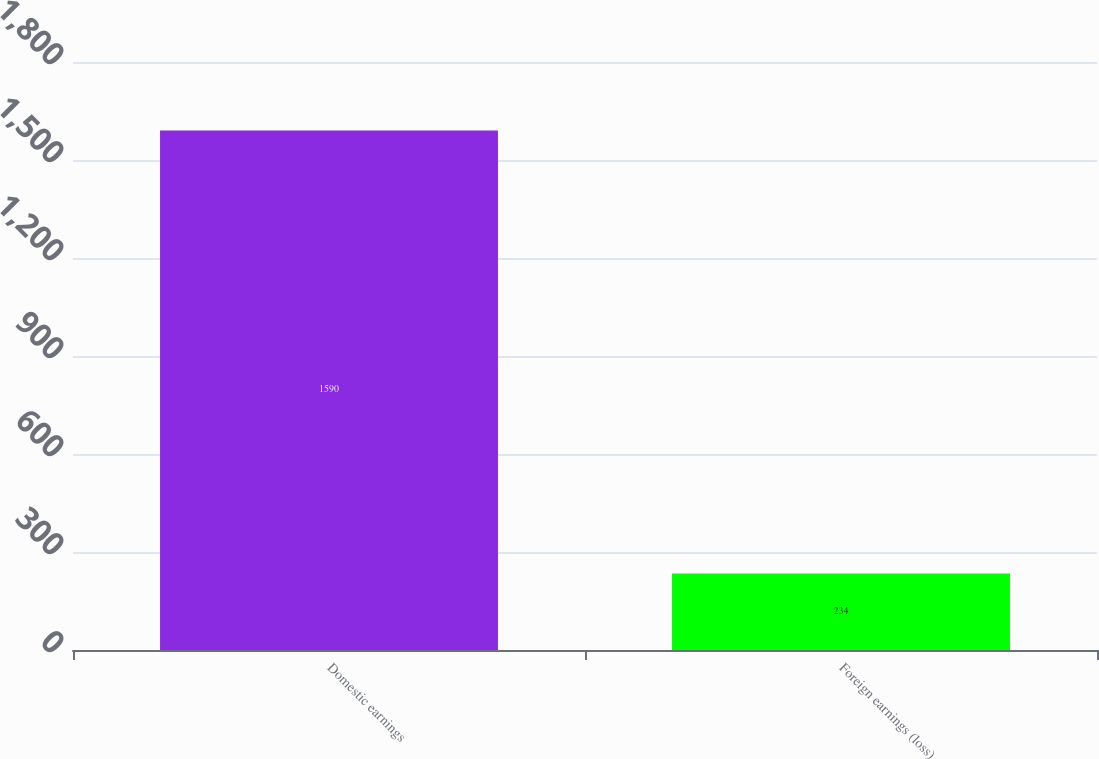Convert chart to OTSL. <chart><loc_0><loc_0><loc_500><loc_500><bar_chart><fcel>Domestic earnings<fcel>Foreign earnings (loss)<nl><fcel>1590<fcel>234<nl></chart> 